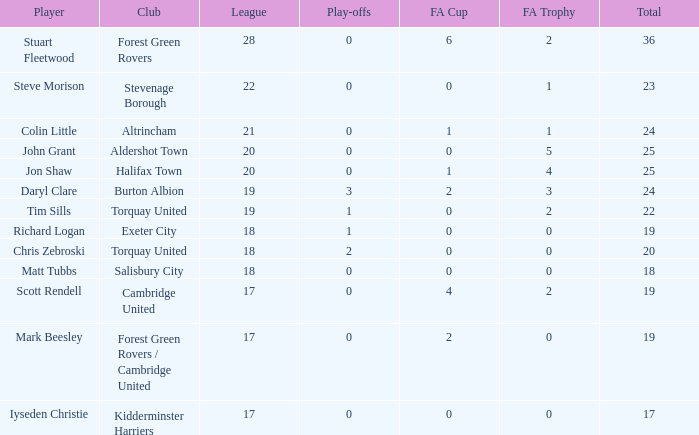Which mean total had Tim Sills as a player? 22.0. 